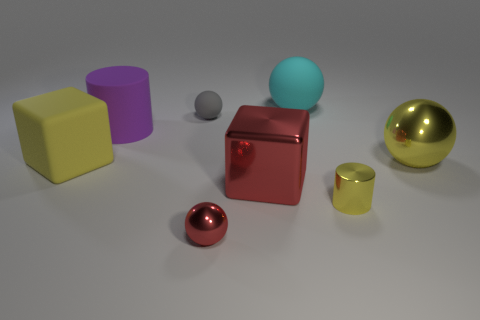Is there any other thing that has the same color as the small rubber object?
Offer a very short reply. No. Are there more big objects behind the tiny gray matte thing than big purple things on the left side of the yellow ball?
Make the answer very short. No. How many things are the same size as the matte cube?
Give a very brief answer. 4. Is the number of metallic cylinders that are on the left side of the small red ball less than the number of large yellow blocks to the right of the metal block?
Keep it short and to the point. No. Is there a red metal thing of the same shape as the big yellow matte thing?
Ensure brevity in your answer.  Yes. Does the tiny red shiny object have the same shape as the cyan object?
Offer a terse response. Yes. What number of big objects are either gray objects or red metallic things?
Provide a succinct answer. 1. Is the number of large metal balls greater than the number of tiny objects?
Offer a very short reply. No. The cylinder that is made of the same material as the large yellow sphere is what size?
Make the answer very short. Small. There is a yellow thing that is on the left side of the big matte cylinder; is it the same size as the metal ball that is behind the big red block?
Your answer should be very brief. Yes. 